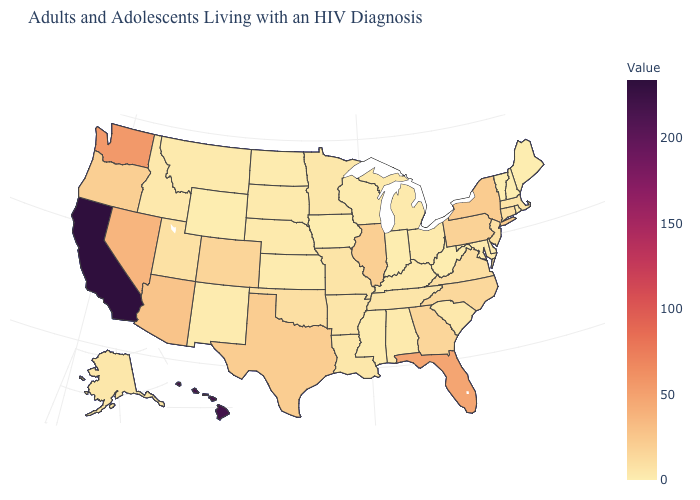Among the states that border Rhode Island , does Connecticut have the highest value?
Quick response, please. Yes. Is the legend a continuous bar?
Write a very short answer. Yes. Which states have the lowest value in the USA?
Answer briefly. Indiana, Iowa, Maine, New Hampshire, Vermont, West Virginia, Wyoming. Does Vermont have the highest value in the USA?
Answer briefly. No. Which states have the highest value in the USA?
Quick response, please. California. Does Georgia have the highest value in the South?
Write a very short answer. No. 